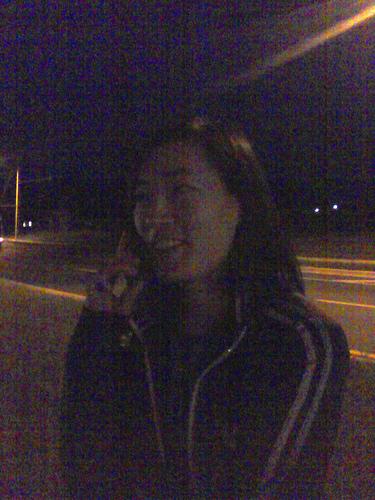Is the woman talking on the phone?
Short answer required. Yes. What is in the woman's hand?
Write a very short answer. Phone. What time of day is this?
Write a very short answer. Night. 